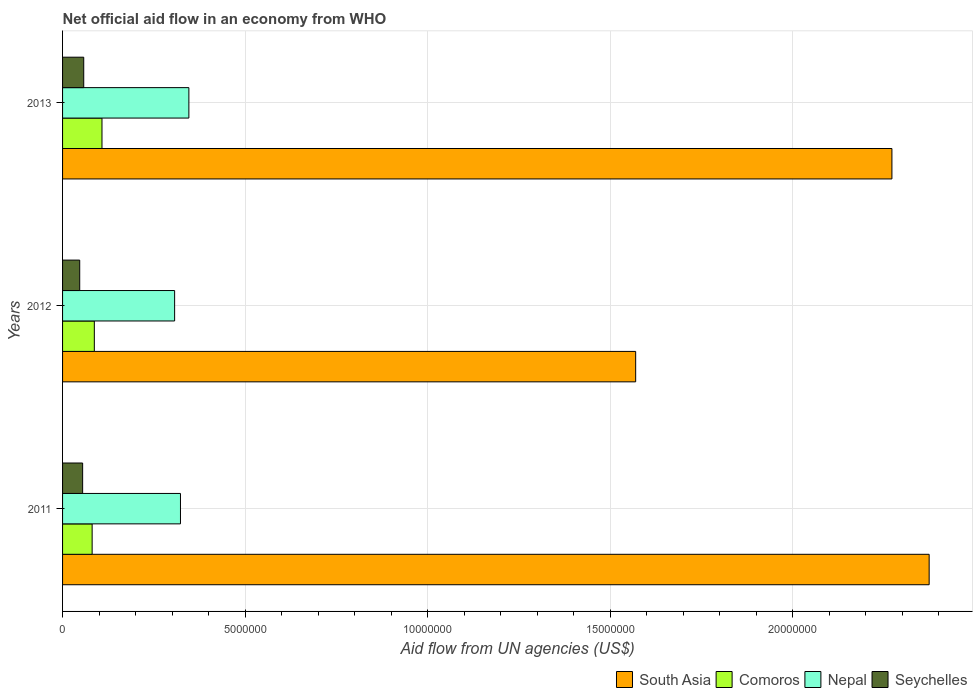Are the number of bars on each tick of the Y-axis equal?
Keep it short and to the point. Yes. How many bars are there on the 1st tick from the top?
Ensure brevity in your answer.  4. What is the label of the 3rd group of bars from the top?
Make the answer very short. 2011. What is the net official aid flow in Nepal in 2012?
Keep it short and to the point. 3.07e+06. Across all years, what is the maximum net official aid flow in Nepal?
Give a very brief answer. 3.46e+06. In which year was the net official aid flow in South Asia maximum?
Your answer should be compact. 2011. In which year was the net official aid flow in South Asia minimum?
Provide a succinct answer. 2012. What is the total net official aid flow in South Asia in the graph?
Offer a terse response. 6.22e+07. What is the difference between the net official aid flow in Nepal in 2011 and that in 2013?
Ensure brevity in your answer.  -2.30e+05. What is the difference between the net official aid flow in Nepal in 2011 and the net official aid flow in South Asia in 2013?
Offer a very short reply. -1.95e+07. What is the average net official aid flow in Nepal per year?
Make the answer very short. 3.25e+06. In the year 2013, what is the difference between the net official aid flow in Nepal and net official aid flow in Seychelles?
Keep it short and to the point. 2.88e+06. In how many years, is the net official aid flow in Comoros greater than 23000000 US$?
Provide a short and direct response. 0. What is the ratio of the net official aid flow in Seychelles in 2012 to that in 2013?
Give a very brief answer. 0.81. Is the net official aid flow in Comoros in 2011 less than that in 2013?
Offer a terse response. Yes. Is the difference between the net official aid flow in Nepal in 2011 and 2012 greater than the difference between the net official aid flow in Seychelles in 2011 and 2012?
Ensure brevity in your answer.  Yes. What is the difference between the highest and the second highest net official aid flow in Seychelles?
Your response must be concise. 3.00e+04. What is the difference between the highest and the lowest net official aid flow in Nepal?
Your answer should be compact. 3.90e+05. In how many years, is the net official aid flow in South Asia greater than the average net official aid flow in South Asia taken over all years?
Provide a succinct answer. 2. Is the sum of the net official aid flow in Comoros in 2011 and 2013 greater than the maximum net official aid flow in South Asia across all years?
Provide a short and direct response. No. Is it the case that in every year, the sum of the net official aid flow in Nepal and net official aid flow in Comoros is greater than the sum of net official aid flow in Seychelles and net official aid flow in South Asia?
Your answer should be compact. Yes. What does the 3rd bar from the top in 2012 represents?
Keep it short and to the point. Comoros. What does the 4th bar from the bottom in 2012 represents?
Provide a short and direct response. Seychelles. How many bars are there?
Your answer should be compact. 12. What is the difference between two consecutive major ticks on the X-axis?
Give a very brief answer. 5.00e+06. Does the graph contain grids?
Make the answer very short. Yes. Where does the legend appear in the graph?
Your answer should be very brief. Bottom right. What is the title of the graph?
Offer a terse response. Net official aid flow in an economy from WHO. What is the label or title of the X-axis?
Give a very brief answer. Aid flow from UN agencies (US$). What is the Aid flow from UN agencies (US$) in South Asia in 2011?
Your response must be concise. 2.37e+07. What is the Aid flow from UN agencies (US$) of Comoros in 2011?
Make the answer very short. 8.10e+05. What is the Aid flow from UN agencies (US$) of Nepal in 2011?
Make the answer very short. 3.23e+06. What is the Aid flow from UN agencies (US$) of South Asia in 2012?
Provide a short and direct response. 1.57e+07. What is the Aid flow from UN agencies (US$) in Comoros in 2012?
Give a very brief answer. 8.70e+05. What is the Aid flow from UN agencies (US$) of Nepal in 2012?
Provide a succinct answer. 3.07e+06. What is the Aid flow from UN agencies (US$) in South Asia in 2013?
Provide a short and direct response. 2.27e+07. What is the Aid flow from UN agencies (US$) in Comoros in 2013?
Your response must be concise. 1.08e+06. What is the Aid flow from UN agencies (US$) of Nepal in 2013?
Provide a succinct answer. 3.46e+06. What is the Aid flow from UN agencies (US$) in Seychelles in 2013?
Your answer should be compact. 5.80e+05. Across all years, what is the maximum Aid flow from UN agencies (US$) in South Asia?
Offer a terse response. 2.37e+07. Across all years, what is the maximum Aid flow from UN agencies (US$) of Comoros?
Make the answer very short. 1.08e+06. Across all years, what is the maximum Aid flow from UN agencies (US$) in Nepal?
Offer a very short reply. 3.46e+06. Across all years, what is the maximum Aid flow from UN agencies (US$) of Seychelles?
Offer a very short reply. 5.80e+05. Across all years, what is the minimum Aid flow from UN agencies (US$) in South Asia?
Offer a very short reply. 1.57e+07. Across all years, what is the minimum Aid flow from UN agencies (US$) in Comoros?
Offer a very short reply. 8.10e+05. Across all years, what is the minimum Aid flow from UN agencies (US$) of Nepal?
Your answer should be compact. 3.07e+06. Across all years, what is the minimum Aid flow from UN agencies (US$) of Seychelles?
Give a very brief answer. 4.70e+05. What is the total Aid flow from UN agencies (US$) of South Asia in the graph?
Provide a succinct answer. 6.22e+07. What is the total Aid flow from UN agencies (US$) in Comoros in the graph?
Ensure brevity in your answer.  2.76e+06. What is the total Aid flow from UN agencies (US$) of Nepal in the graph?
Your response must be concise. 9.76e+06. What is the total Aid flow from UN agencies (US$) of Seychelles in the graph?
Offer a very short reply. 1.60e+06. What is the difference between the Aid flow from UN agencies (US$) of South Asia in 2011 and that in 2012?
Give a very brief answer. 8.04e+06. What is the difference between the Aid flow from UN agencies (US$) of South Asia in 2011 and that in 2013?
Ensure brevity in your answer.  1.02e+06. What is the difference between the Aid flow from UN agencies (US$) in Comoros in 2011 and that in 2013?
Provide a succinct answer. -2.70e+05. What is the difference between the Aid flow from UN agencies (US$) of Nepal in 2011 and that in 2013?
Your answer should be very brief. -2.30e+05. What is the difference between the Aid flow from UN agencies (US$) in South Asia in 2012 and that in 2013?
Give a very brief answer. -7.02e+06. What is the difference between the Aid flow from UN agencies (US$) in Comoros in 2012 and that in 2013?
Ensure brevity in your answer.  -2.10e+05. What is the difference between the Aid flow from UN agencies (US$) of Nepal in 2012 and that in 2013?
Provide a short and direct response. -3.90e+05. What is the difference between the Aid flow from UN agencies (US$) in South Asia in 2011 and the Aid flow from UN agencies (US$) in Comoros in 2012?
Keep it short and to the point. 2.29e+07. What is the difference between the Aid flow from UN agencies (US$) in South Asia in 2011 and the Aid flow from UN agencies (US$) in Nepal in 2012?
Ensure brevity in your answer.  2.07e+07. What is the difference between the Aid flow from UN agencies (US$) of South Asia in 2011 and the Aid flow from UN agencies (US$) of Seychelles in 2012?
Your answer should be very brief. 2.33e+07. What is the difference between the Aid flow from UN agencies (US$) of Comoros in 2011 and the Aid flow from UN agencies (US$) of Nepal in 2012?
Keep it short and to the point. -2.26e+06. What is the difference between the Aid flow from UN agencies (US$) in Nepal in 2011 and the Aid flow from UN agencies (US$) in Seychelles in 2012?
Ensure brevity in your answer.  2.76e+06. What is the difference between the Aid flow from UN agencies (US$) of South Asia in 2011 and the Aid flow from UN agencies (US$) of Comoros in 2013?
Give a very brief answer. 2.27e+07. What is the difference between the Aid flow from UN agencies (US$) of South Asia in 2011 and the Aid flow from UN agencies (US$) of Nepal in 2013?
Keep it short and to the point. 2.03e+07. What is the difference between the Aid flow from UN agencies (US$) in South Asia in 2011 and the Aid flow from UN agencies (US$) in Seychelles in 2013?
Offer a terse response. 2.32e+07. What is the difference between the Aid flow from UN agencies (US$) in Comoros in 2011 and the Aid flow from UN agencies (US$) in Nepal in 2013?
Provide a succinct answer. -2.65e+06. What is the difference between the Aid flow from UN agencies (US$) of Comoros in 2011 and the Aid flow from UN agencies (US$) of Seychelles in 2013?
Offer a very short reply. 2.30e+05. What is the difference between the Aid flow from UN agencies (US$) in Nepal in 2011 and the Aid flow from UN agencies (US$) in Seychelles in 2013?
Provide a succinct answer. 2.65e+06. What is the difference between the Aid flow from UN agencies (US$) in South Asia in 2012 and the Aid flow from UN agencies (US$) in Comoros in 2013?
Your response must be concise. 1.46e+07. What is the difference between the Aid flow from UN agencies (US$) in South Asia in 2012 and the Aid flow from UN agencies (US$) in Nepal in 2013?
Your response must be concise. 1.22e+07. What is the difference between the Aid flow from UN agencies (US$) of South Asia in 2012 and the Aid flow from UN agencies (US$) of Seychelles in 2013?
Your response must be concise. 1.51e+07. What is the difference between the Aid flow from UN agencies (US$) of Comoros in 2012 and the Aid flow from UN agencies (US$) of Nepal in 2013?
Provide a short and direct response. -2.59e+06. What is the difference between the Aid flow from UN agencies (US$) of Comoros in 2012 and the Aid flow from UN agencies (US$) of Seychelles in 2013?
Provide a succinct answer. 2.90e+05. What is the difference between the Aid flow from UN agencies (US$) of Nepal in 2012 and the Aid flow from UN agencies (US$) of Seychelles in 2013?
Make the answer very short. 2.49e+06. What is the average Aid flow from UN agencies (US$) of South Asia per year?
Give a very brief answer. 2.07e+07. What is the average Aid flow from UN agencies (US$) of Comoros per year?
Ensure brevity in your answer.  9.20e+05. What is the average Aid flow from UN agencies (US$) in Nepal per year?
Provide a succinct answer. 3.25e+06. What is the average Aid flow from UN agencies (US$) of Seychelles per year?
Your response must be concise. 5.33e+05. In the year 2011, what is the difference between the Aid flow from UN agencies (US$) of South Asia and Aid flow from UN agencies (US$) of Comoros?
Your answer should be very brief. 2.29e+07. In the year 2011, what is the difference between the Aid flow from UN agencies (US$) in South Asia and Aid flow from UN agencies (US$) in Nepal?
Give a very brief answer. 2.05e+07. In the year 2011, what is the difference between the Aid flow from UN agencies (US$) of South Asia and Aid flow from UN agencies (US$) of Seychelles?
Your answer should be compact. 2.32e+07. In the year 2011, what is the difference between the Aid flow from UN agencies (US$) in Comoros and Aid flow from UN agencies (US$) in Nepal?
Offer a terse response. -2.42e+06. In the year 2011, what is the difference between the Aid flow from UN agencies (US$) in Nepal and Aid flow from UN agencies (US$) in Seychelles?
Give a very brief answer. 2.68e+06. In the year 2012, what is the difference between the Aid flow from UN agencies (US$) in South Asia and Aid flow from UN agencies (US$) in Comoros?
Ensure brevity in your answer.  1.48e+07. In the year 2012, what is the difference between the Aid flow from UN agencies (US$) in South Asia and Aid flow from UN agencies (US$) in Nepal?
Your answer should be very brief. 1.26e+07. In the year 2012, what is the difference between the Aid flow from UN agencies (US$) of South Asia and Aid flow from UN agencies (US$) of Seychelles?
Your response must be concise. 1.52e+07. In the year 2012, what is the difference between the Aid flow from UN agencies (US$) in Comoros and Aid flow from UN agencies (US$) in Nepal?
Offer a very short reply. -2.20e+06. In the year 2012, what is the difference between the Aid flow from UN agencies (US$) of Comoros and Aid flow from UN agencies (US$) of Seychelles?
Your answer should be very brief. 4.00e+05. In the year 2012, what is the difference between the Aid flow from UN agencies (US$) in Nepal and Aid flow from UN agencies (US$) in Seychelles?
Your answer should be compact. 2.60e+06. In the year 2013, what is the difference between the Aid flow from UN agencies (US$) in South Asia and Aid flow from UN agencies (US$) in Comoros?
Make the answer very short. 2.16e+07. In the year 2013, what is the difference between the Aid flow from UN agencies (US$) in South Asia and Aid flow from UN agencies (US$) in Nepal?
Provide a succinct answer. 1.93e+07. In the year 2013, what is the difference between the Aid flow from UN agencies (US$) in South Asia and Aid flow from UN agencies (US$) in Seychelles?
Your answer should be compact. 2.21e+07. In the year 2013, what is the difference between the Aid flow from UN agencies (US$) in Comoros and Aid flow from UN agencies (US$) in Nepal?
Give a very brief answer. -2.38e+06. In the year 2013, what is the difference between the Aid flow from UN agencies (US$) in Comoros and Aid flow from UN agencies (US$) in Seychelles?
Your answer should be compact. 5.00e+05. In the year 2013, what is the difference between the Aid flow from UN agencies (US$) in Nepal and Aid flow from UN agencies (US$) in Seychelles?
Offer a terse response. 2.88e+06. What is the ratio of the Aid flow from UN agencies (US$) in South Asia in 2011 to that in 2012?
Your answer should be very brief. 1.51. What is the ratio of the Aid flow from UN agencies (US$) of Comoros in 2011 to that in 2012?
Give a very brief answer. 0.93. What is the ratio of the Aid flow from UN agencies (US$) in Nepal in 2011 to that in 2012?
Your answer should be compact. 1.05. What is the ratio of the Aid flow from UN agencies (US$) of Seychelles in 2011 to that in 2012?
Provide a short and direct response. 1.17. What is the ratio of the Aid flow from UN agencies (US$) of South Asia in 2011 to that in 2013?
Keep it short and to the point. 1.04. What is the ratio of the Aid flow from UN agencies (US$) in Nepal in 2011 to that in 2013?
Your answer should be very brief. 0.93. What is the ratio of the Aid flow from UN agencies (US$) in Seychelles in 2011 to that in 2013?
Offer a very short reply. 0.95. What is the ratio of the Aid flow from UN agencies (US$) of South Asia in 2012 to that in 2013?
Your answer should be compact. 0.69. What is the ratio of the Aid flow from UN agencies (US$) in Comoros in 2012 to that in 2013?
Provide a short and direct response. 0.81. What is the ratio of the Aid flow from UN agencies (US$) of Nepal in 2012 to that in 2013?
Your answer should be compact. 0.89. What is the ratio of the Aid flow from UN agencies (US$) in Seychelles in 2012 to that in 2013?
Offer a terse response. 0.81. What is the difference between the highest and the second highest Aid flow from UN agencies (US$) in South Asia?
Provide a succinct answer. 1.02e+06. What is the difference between the highest and the lowest Aid flow from UN agencies (US$) of South Asia?
Keep it short and to the point. 8.04e+06. What is the difference between the highest and the lowest Aid flow from UN agencies (US$) of Comoros?
Your answer should be very brief. 2.70e+05. What is the difference between the highest and the lowest Aid flow from UN agencies (US$) in Nepal?
Make the answer very short. 3.90e+05. What is the difference between the highest and the lowest Aid flow from UN agencies (US$) in Seychelles?
Keep it short and to the point. 1.10e+05. 